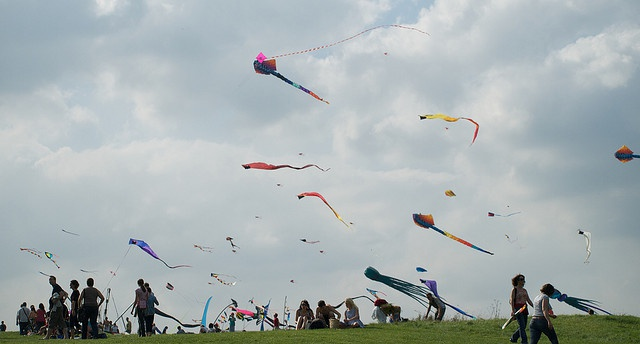Describe the objects in this image and their specific colors. I can see kite in darkgray, lightgray, and black tones, people in darkgray, black, darkgreen, and gray tones, people in darkgray, black, darkgreen, and gray tones, kite in darkgray, black, lightgray, and gray tones, and people in darkgray, black, gray, and lightgray tones in this image. 